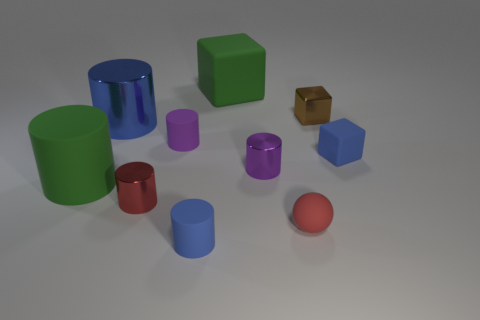There is a large matte thing that is the same color as the big matte cylinder; what is its shape?
Your answer should be compact. Cube. What is the size of the rubber thing that is the same color as the tiny matte block?
Give a very brief answer. Small. There is a big blue metal cylinder; are there any small blocks behind it?
Offer a terse response. Yes. What size is the red thing that is the same shape as the purple rubber thing?
Keep it short and to the point. Small. Is there any other thing that has the same size as the blue metallic object?
Provide a short and direct response. Yes. Is the shape of the purple matte object the same as the purple metal object?
Offer a terse response. Yes. There is a blue cylinder that is behind the big rubber object in front of the small brown metallic block; what is its size?
Provide a succinct answer. Large. The big object that is the same shape as the small brown shiny thing is what color?
Give a very brief answer. Green. How many shiny blocks are the same color as the big rubber block?
Provide a succinct answer. 0. What size is the blue rubber block?
Your response must be concise. Small. 